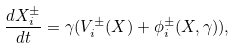<formula> <loc_0><loc_0><loc_500><loc_500>\frac { d X _ { i } ^ { \pm } } { d t } = \gamma ( V _ { i } ^ { \pm } ( X ) + \phi _ { i } ^ { \pm } ( X , \gamma ) ) ,</formula> 